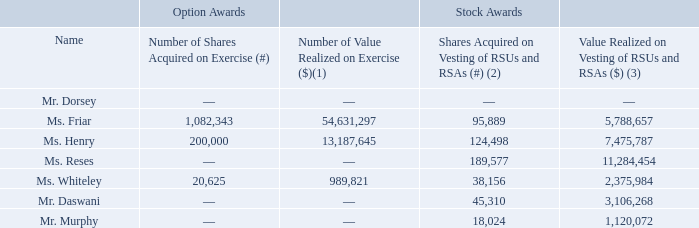Option Exercises and Stock Vested in 2018
The following table sets forth the number of shares of common stock acquired during 2018 by our named executive officers upon the exercise of stock options or upon the vesting of RSUs or RSAs, as well as the value realized upon such equity award transactions.
(1) Calculated by multiplying (i) the fair market value of Class A common stock on the vesting date, which was determined using the closing price on the New York Stock Exchange of a share of Class A common stock on the date of vest, or if such day is a holiday, on the immediately preceding trading day less the option exercise price paid for such shares of common stock, by (ii) the number of shares of common stock acquired upon exercise.
(2) Reflects the aggregate number of shares of Class A common stock underlying RSUs and RSAs that vested in 2018. Of the amount shown for Messrs. Daswani and Murphy and Mses. Friar, Henry, Reses and Whiteley, 20,132, 6,741, 44,857, 59,014, 91,306 and 17,217 shares, respectively, of Class A common stock were withheld to cover tax withholding obligations upon vesting.
(3) Calculated by multiplying (i) the fair market value of Class A common stock on the vesting date, which was determined using the closing price on the New York Stock Exchange of a share of common stock on the date of vest, or if such day is a holiday, on the immediately preceding trading day, by (ii) the number of shares of common stock acquired upon vesting. Of the amount shown for Messrs. Daswani and Murphy and Mses. Friar, Henry, Reses and Whiteley, $1,389,704, $414,596, $2,782,628, $3,619,149, $5,502,076 and $1,114,287, respectively, represents the value of shares withheld to cover tax withholding obligations upon vesting.
What does the table show? The number of shares of common stock acquired during 2018 by our named executive officers upon the exercise of stock options or upon the vesting of rsus or rsas, as well as the value realized upon such equity award transactions. What does the Number of Shares Acquired on Vesting of RSUs and RSAs column show? Reflects the aggregate number of shares of class a common stock underlying rsus and rsas that vested in 2018. What is the Number of Shares Acquired on Exercise for Ms Friar? 1,082,343. What is the average Number of Shares Acquired on Exercise for the 3 officers who received it? (1,082,343 + 200,000 + 20,625) / 3 
Answer: 434322.67. What is the difference between the largest and smallest Value Realized on Vesting of RSUs and RSAs? 11,284,454 - 1,120,072 
Answer: 10164382. Who has the largest amount of  Number of Shares Acquired on Vesting of RSUs and RSAs? From COL5 find the largest number and the corresponding name in COL 2  
Answer: ms. reses. 